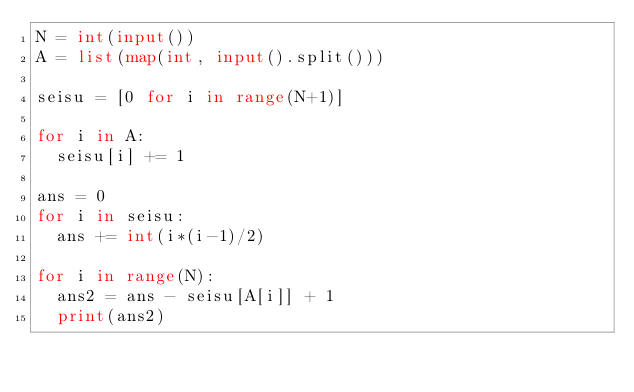<code> <loc_0><loc_0><loc_500><loc_500><_Python_>N = int(input())
A = list(map(int, input().split()))

seisu = [0 for i in range(N+1)]

for i in A:
  seisu[i] += 1
  
ans = 0
for i in seisu:
  ans += int(i*(i-1)/2)

for i in range(N):
  ans2 = ans - seisu[A[i]] + 1
  print(ans2)</code> 